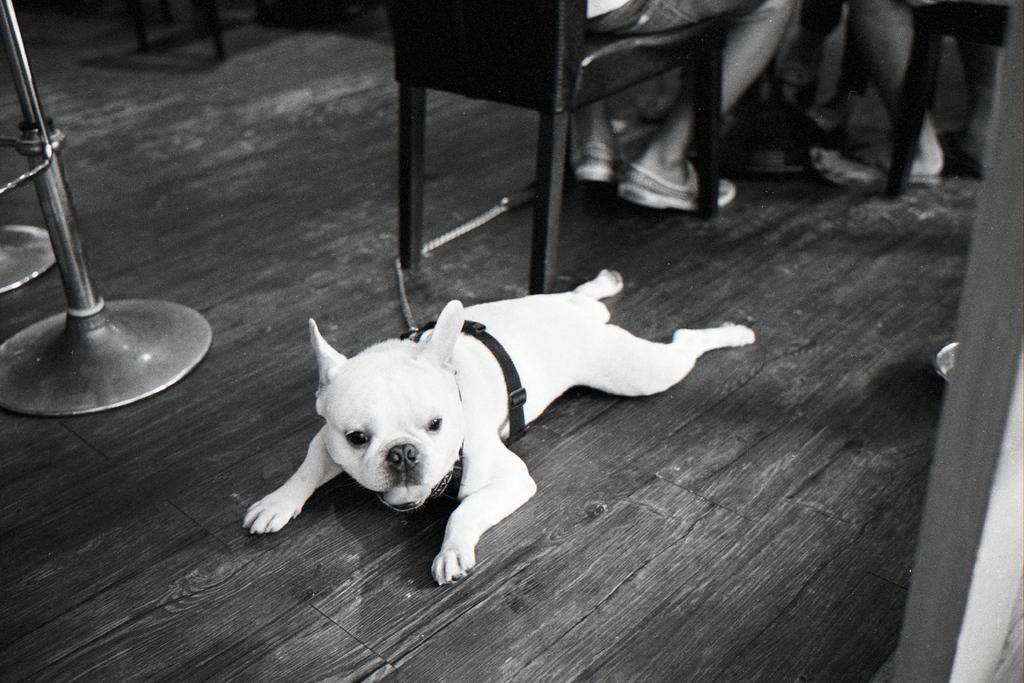What animal can be seen lying on the floor in the image? There is a dog lying on the floor in the image. What is the position of the person in the image? The person is sitting on a chair in the image. What part of the person's body is visible in the image? The person's legs are visible in the image. What can be seen on the left side of the image? There is a stand on the left side of the image. How many visitors are present in the image? There is no mention of visitors in the image; it only features a dog and a person. What type of brush is being used by the person in the image? There is no brush present in the image. 